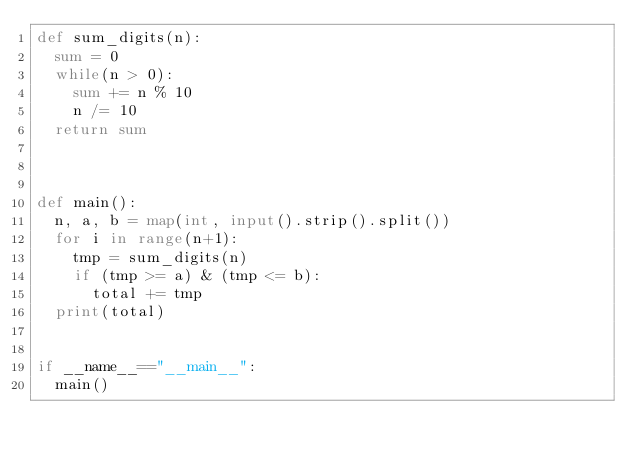<code> <loc_0><loc_0><loc_500><loc_500><_Python_>def sum_digits(n):
  sum = 0
  while(n > 0):
    sum += n % 10
    n /= 10
  return sum
   
 
  
def main():
  n, a, b = map(int, input().strip().split())
  for i in range(n+1):
    tmp = sum_digits(n)
    if (tmp >= a) & (tmp <= b):
      total += tmp
  print(total)
 
    
if __name__=="__main__":
  main()</code> 